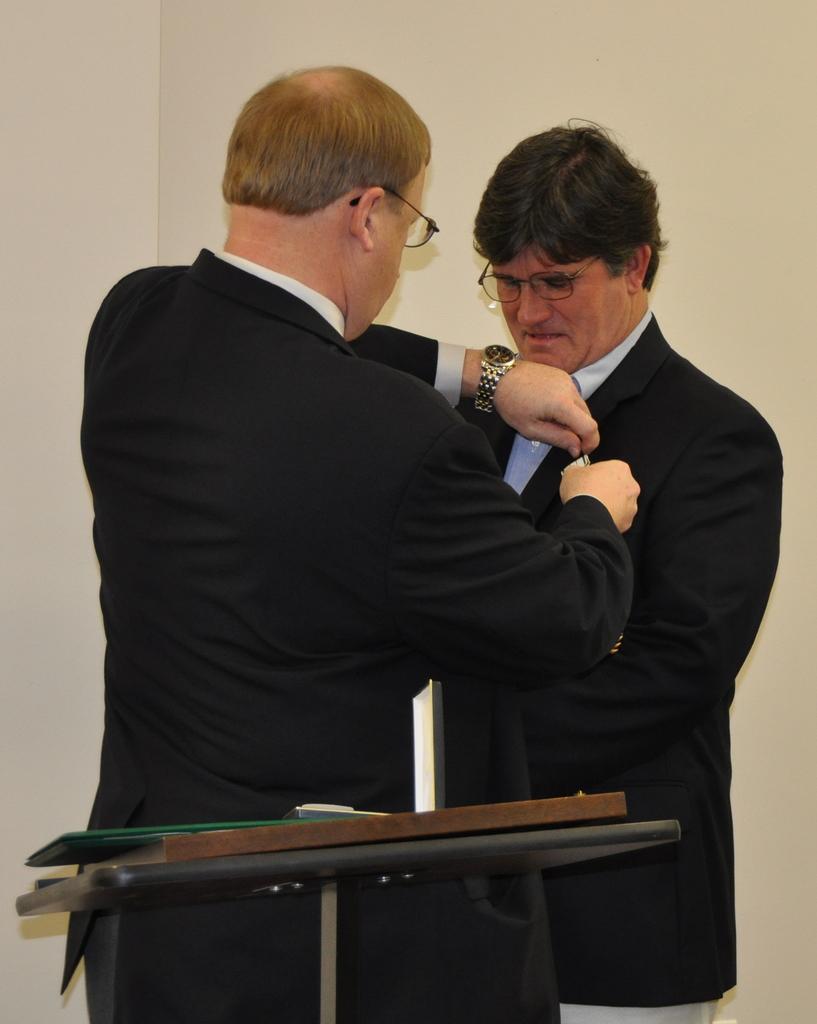Please provide a concise description of this image. In this image I can see two men in black dresses. I can also see they both are wearing specs. I can see watch in one man's hand. 